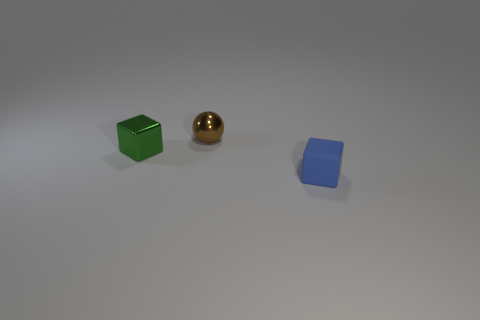Add 3 cyan spheres. How many objects exist? 6 Subtract all blocks. How many objects are left? 1 Add 3 small rubber cubes. How many small rubber cubes are left? 4 Add 1 small yellow metallic balls. How many small yellow metallic balls exist? 1 Subtract 0 purple cylinders. How many objects are left? 3 Subtract all tiny purple rubber cylinders. Subtract all matte cubes. How many objects are left? 2 